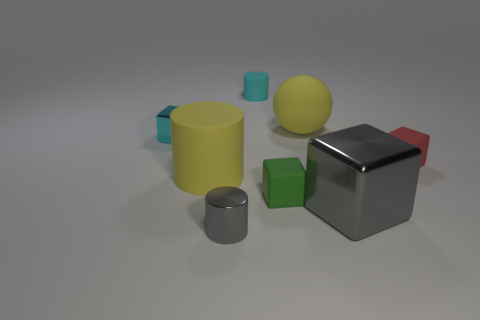Are there more big cubes behind the tiny gray shiny object than tiny cyan cylinders that are left of the big cylinder? Indeed, there are more large cubes situated behind the small, shiny grey object when compared to the number of small cyan cylinders located to the left side of the large cylinder. 